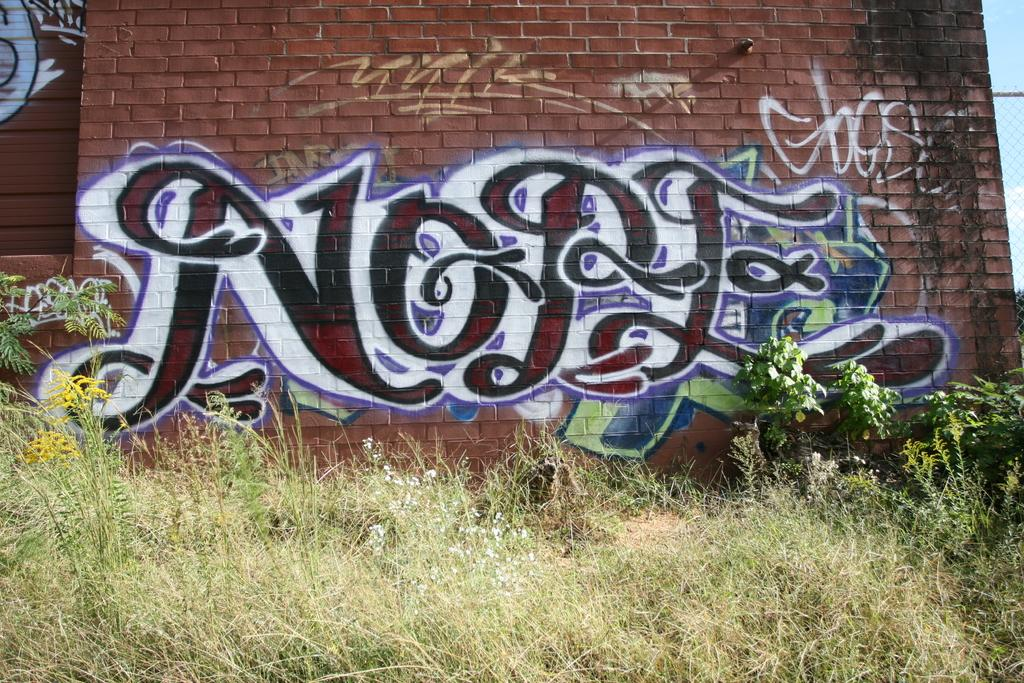What is present in the picture? There is a wall in the picture. What can be said about the appearance of the wall? The wall is painted. What type of vegetation is visible in front of the wall? There is grass in front of the wall. What type of fuel is being used by the committee in the image? There is no committee or fuel present in the image; it features a painted wall with grass in front of it. 